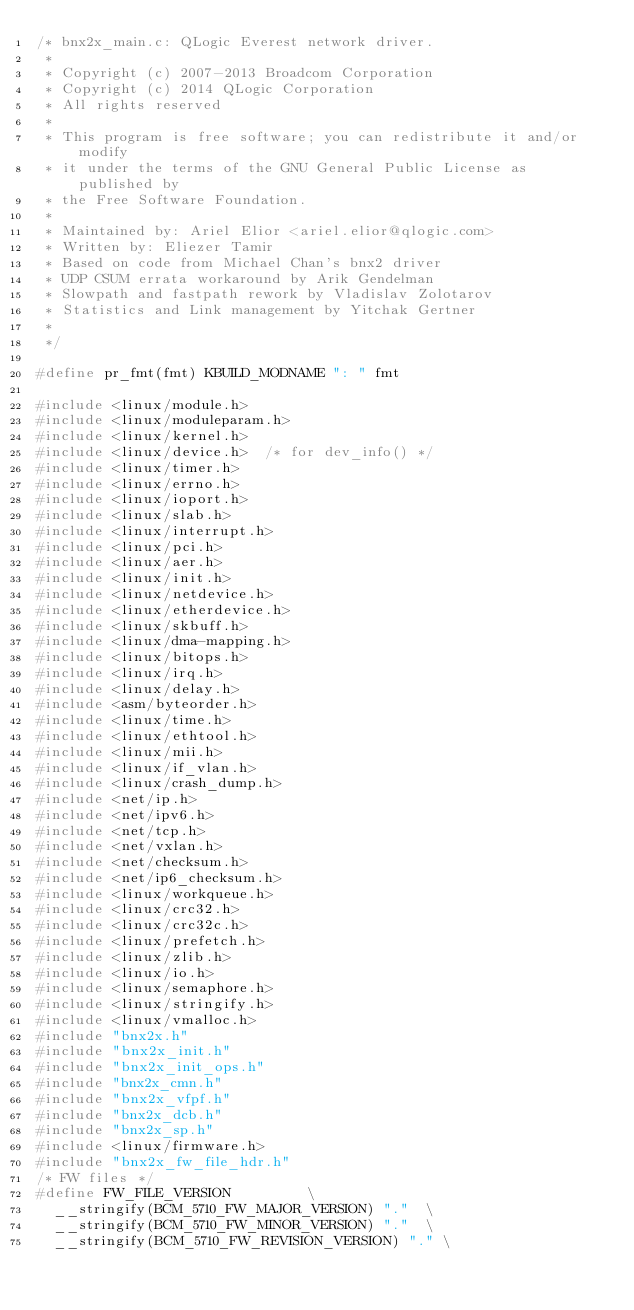<code> <loc_0><loc_0><loc_500><loc_500><_C_>/* bnx2x_main.c: QLogic Everest network driver.
 *
 * Copyright (c) 2007-2013 Broadcom Corporation
 * Copyright (c) 2014 QLogic Corporation
 * All rights reserved
 *
 * This program is free software; you can redistribute it and/or modify
 * it under the terms of the GNU General Public License as published by
 * the Free Software Foundation.
 *
 * Maintained by: Ariel Elior <ariel.elior@qlogic.com>
 * Written by: Eliezer Tamir
 * Based on code from Michael Chan's bnx2 driver
 * UDP CSUM errata workaround by Arik Gendelman
 * Slowpath and fastpath rework by Vladislav Zolotarov
 * Statistics and Link management by Yitchak Gertner
 *
 */

#define pr_fmt(fmt) KBUILD_MODNAME ": " fmt

#include <linux/module.h>
#include <linux/moduleparam.h>
#include <linux/kernel.h>
#include <linux/device.h>  /* for dev_info() */
#include <linux/timer.h>
#include <linux/errno.h>
#include <linux/ioport.h>
#include <linux/slab.h>
#include <linux/interrupt.h>
#include <linux/pci.h>
#include <linux/aer.h>
#include <linux/init.h>
#include <linux/netdevice.h>
#include <linux/etherdevice.h>
#include <linux/skbuff.h>
#include <linux/dma-mapping.h>
#include <linux/bitops.h>
#include <linux/irq.h>
#include <linux/delay.h>
#include <asm/byteorder.h>
#include <linux/time.h>
#include <linux/ethtool.h>
#include <linux/mii.h>
#include <linux/if_vlan.h>
#include <linux/crash_dump.h>
#include <net/ip.h>
#include <net/ipv6.h>
#include <net/tcp.h>
#include <net/vxlan.h>
#include <net/checksum.h>
#include <net/ip6_checksum.h>
#include <linux/workqueue.h>
#include <linux/crc32.h>
#include <linux/crc32c.h>
#include <linux/prefetch.h>
#include <linux/zlib.h>
#include <linux/io.h>
#include <linux/semaphore.h>
#include <linux/stringify.h>
#include <linux/vmalloc.h>
#include "bnx2x.h"
#include "bnx2x_init.h"
#include "bnx2x_init_ops.h"
#include "bnx2x_cmn.h"
#include "bnx2x_vfpf.h"
#include "bnx2x_dcb.h"
#include "bnx2x_sp.h"
#include <linux/firmware.h>
#include "bnx2x_fw_file_hdr.h"
/* FW files */
#define FW_FILE_VERSION					\
	__stringify(BCM_5710_FW_MAJOR_VERSION) "."	\
	__stringify(BCM_5710_FW_MINOR_VERSION) "."	\
	__stringify(BCM_5710_FW_REVISION_VERSION) "."	\</code> 